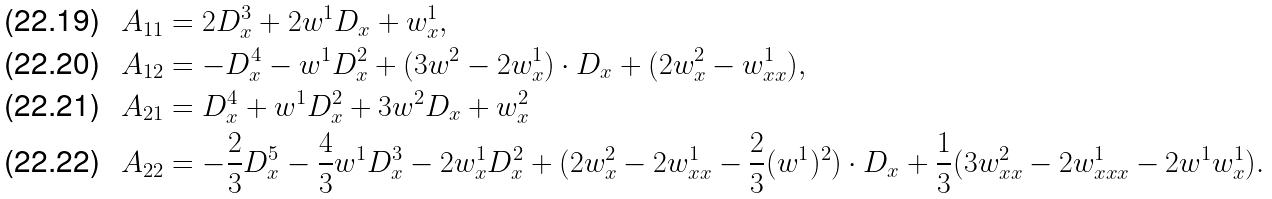Convert formula to latex. <formula><loc_0><loc_0><loc_500><loc_500>A _ { 1 1 } & = 2 D _ { x } ^ { 3 } + 2 w ^ { 1 } D _ { x } + w ^ { 1 } _ { x } , \\ A _ { 1 2 } & = - D _ { x } ^ { 4 } - w ^ { 1 } D _ { x } ^ { 2 } + ( 3 w ^ { 2 } - 2 w ^ { 1 } _ { x } ) \cdot D _ { x } + ( 2 w ^ { 2 } _ { x } - w ^ { 1 } _ { x x } ) , \\ A _ { 2 1 } & = D _ { x } ^ { 4 } + w ^ { 1 } D _ { x } ^ { 2 } + 3 w ^ { 2 } D _ { x } + w ^ { 2 } _ { x } \\ A _ { 2 2 } & = - \frac { 2 } { 3 } D _ { x } ^ { 5 } - \frac { 4 } { 3 } w ^ { 1 } D _ { x } ^ { 3 } - 2 w ^ { 1 } _ { x } D _ { x } ^ { 2 } + ( 2 w ^ { 2 } _ { x } - 2 w ^ { 1 } _ { x x } - \frac { 2 } { 3 } ( w ^ { 1 } ) ^ { 2 } ) \cdot D _ { x } + \frac { 1 } { 3 } ( 3 w ^ { 2 } _ { x x } - 2 w ^ { 1 } _ { x x x } - 2 w ^ { 1 } w ^ { 1 } _ { x } ) .</formula> 